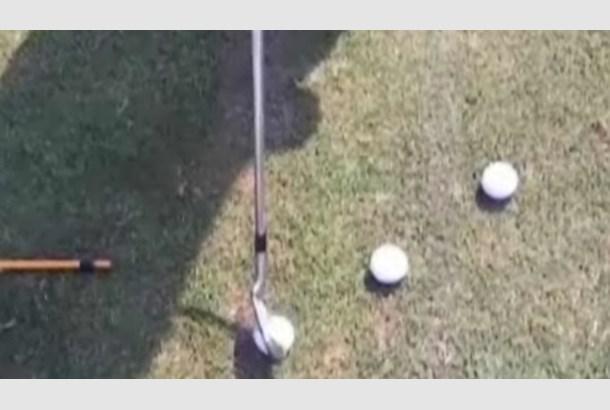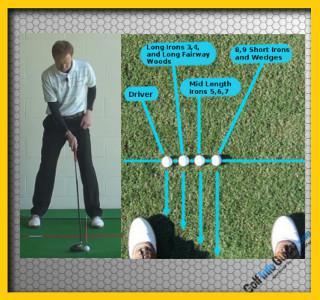The first image is the image on the left, the second image is the image on the right. For the images shown, is this caption "One image shows a golf club and three balls, but no part of a golfer." true? Answer yes or no. Yes. The first image is the image on the left, the second image is the image on the right. Evaluate the accuracy of this statement regarding the images: "The left image contains exactly three golf balls.". Is it true? Answer yes or no. Yes. 